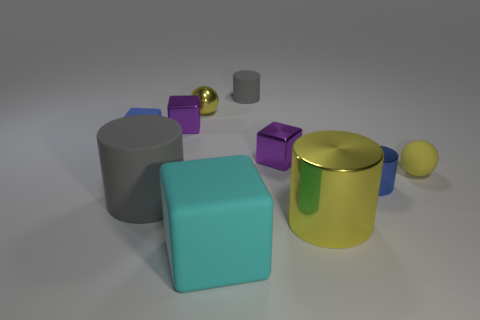How many big cylinders are the same color as the small matte ball?
Make the answer very short. 1. There is a cyan object that is the same shape as the small blue matte thing; what size is it?
Your answer should be compact. Large. The purple object behind the small blue matte object that is left of the tiny rubber cylinder is what shape?
Provide a succinct answer. Cube. How many brown things are either blocks or large things?
Give a very brief answer. 0. The large block is what color?
Keep it short and to the point. Cyan. Do the blue matte thing and the blue cylinder have the same size?
Offer a terse response. Yes. Are there any other things that are the same shape as the big gray object?
Make the answer very short. Yes. Do the large cyan thing and the large cylinder on the left side of the big yellow thing have the same material?
Offer a terse response. Yes. Do the large matte object that is behind the cyan rubber thing and the tiny matte block have the same color?
Your response must be concise. No. What number of small rubber things are both in front of the tiny gray matte object and behind the tiny shiny ball?
Make the answer very short. 0. 